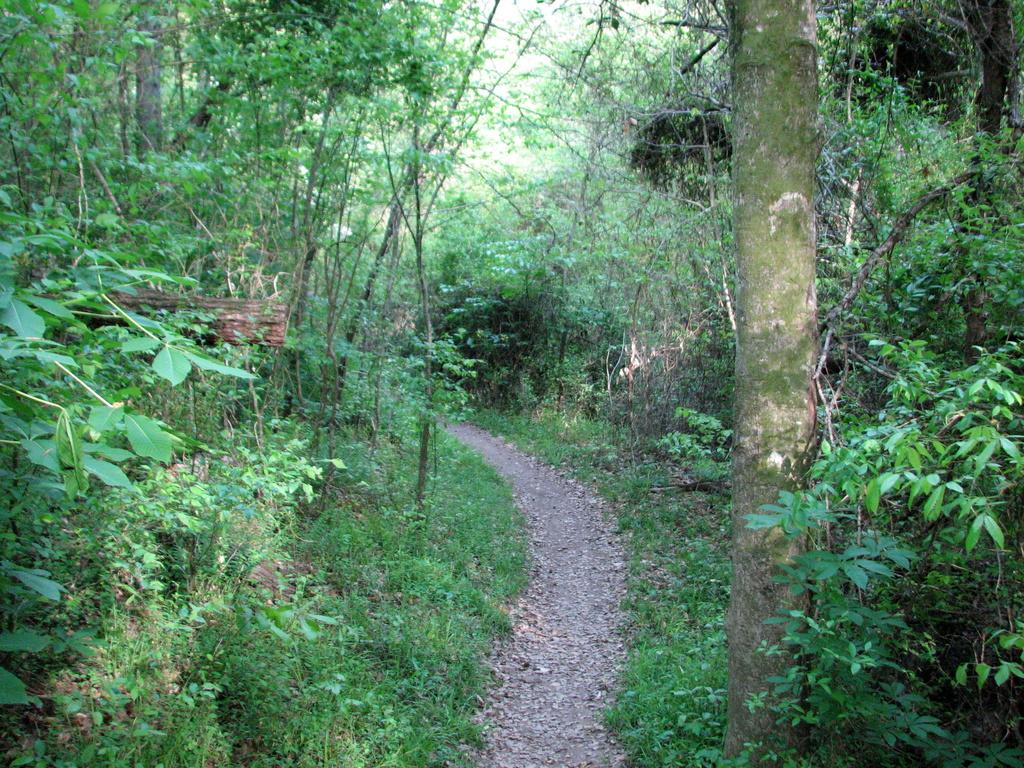What type of vegetation can be seen in the image? There are trees and grass in the image. Can you describe the natural environment depicted in the image? The image features trees and grass, which suggests a natural setting. How many tickets are visible in the image? There are no tickets present in the image. What type of force is being applied to the bridge in the image? There is no bridge present in the image. 